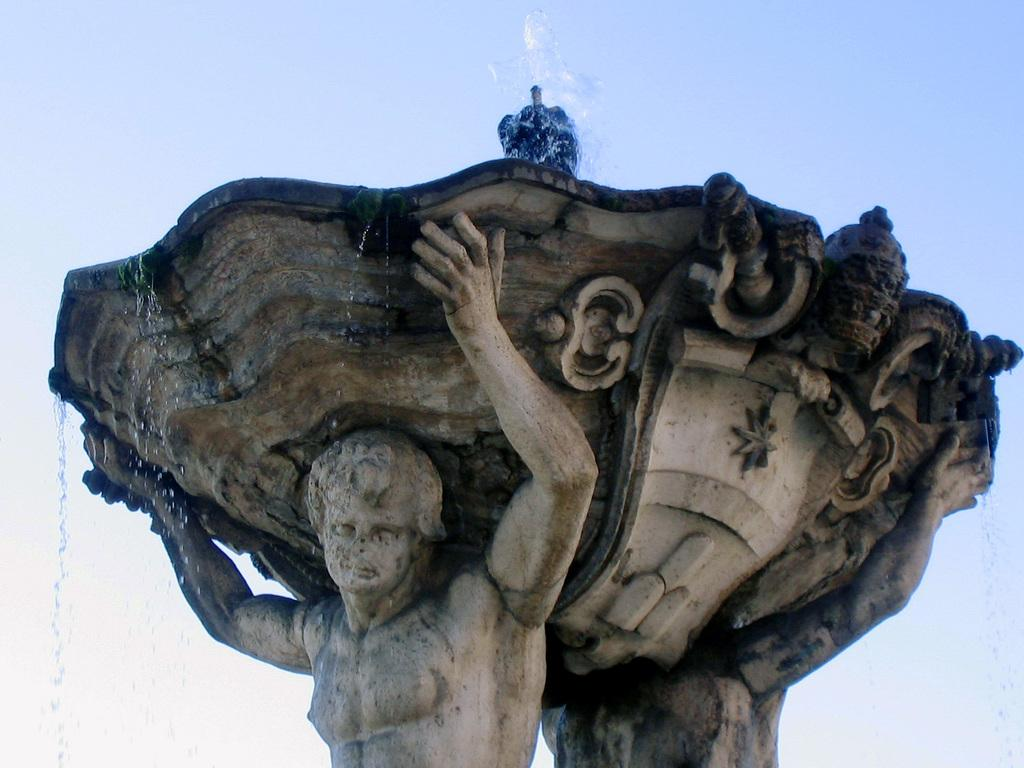What is the main subject in the middle of the image? There is a statue in the middle of the image. What does the statue depict? The statue depicts a person. What is the person holding in their hands? The person is holding a fountain with their hands. What is at the top of the fountain? There is water at the top of the fountain. What type of wilderness can be seen in the background of the image? There is no wilderness visible in the image; it features a statue with a fountain. What is located behind the statue in the image? The provided facts do not mention anything behind the statue, so we cannot answer that question. 